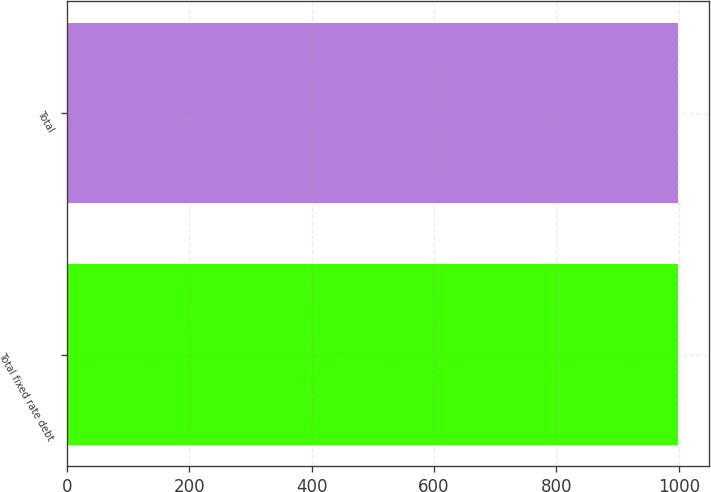Convert chart. <chart><loc_0><loc_0><loc_500><loc_500><bar_chart><fcel>Total fixed rate debt<fcel>Total<nl><fcel>999<fcel>999.1<nl></chart> 